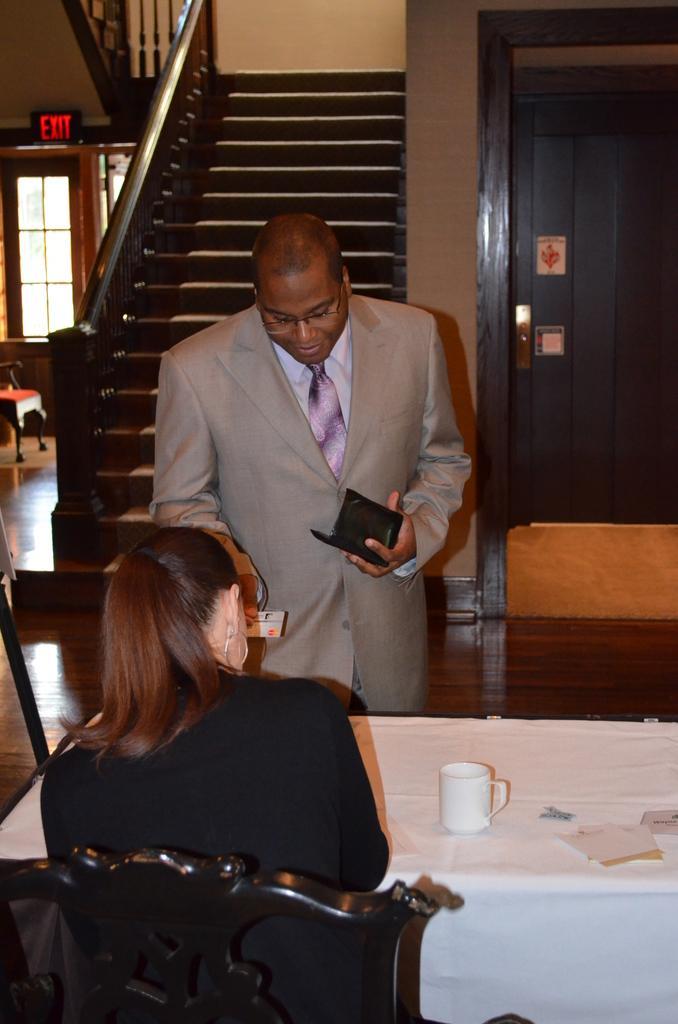Could you give a brief overview of what you see in this image? This is a picture inside a building. In the center of the image a man is standing holding a wallet in his hand. In the foreground a woman is sitting, there is a table in front of her, on the table there is a cup. In the background of the center there is staircase. On the top right there is a door. On the top left there is a window. 